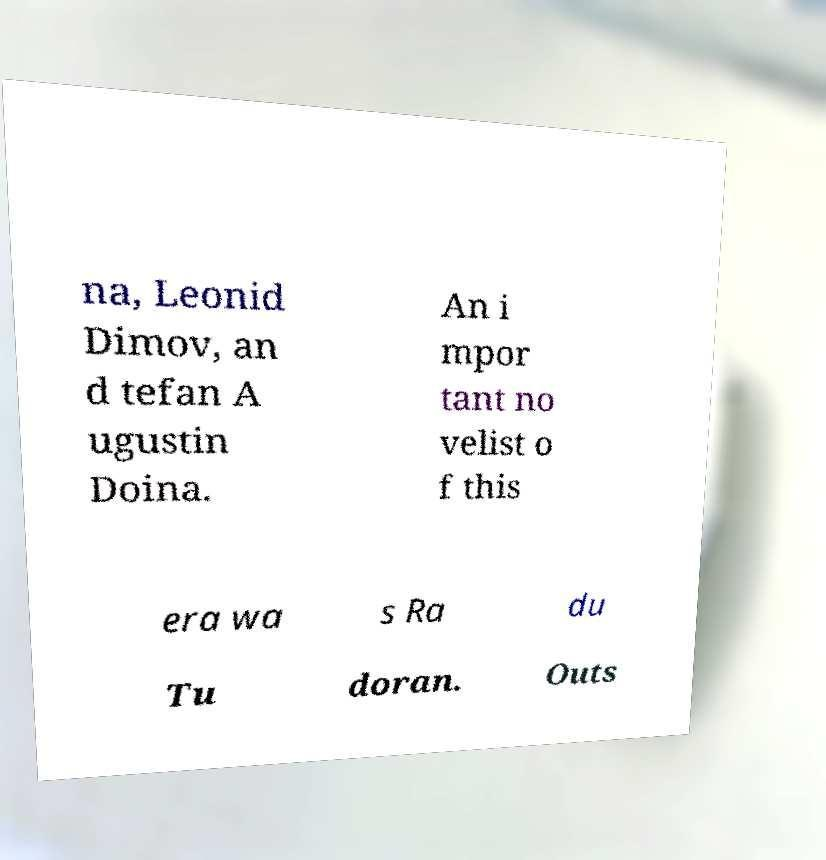I need the written content from this picture converted into text. Can you do that? na, Leonid Dimov, an d tefan A ugustin Doina. An i mpor tant no velist o f this era wa s Ra du Tu doran. Outs 